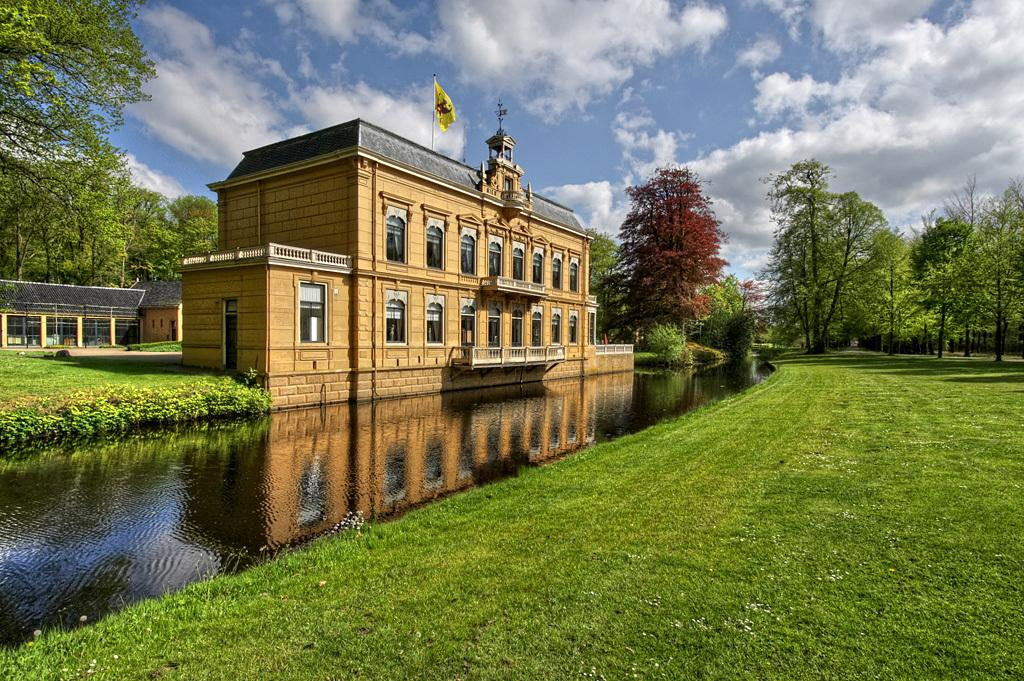What is located on the left side of the image? There are buildings, trees, a flag, water, and grass on the left side of the image. What is the composition of the left side of the image? The left side of the image includes natural elements like trees and water, as well as man-made structures like buildings and a flag. What is visible on the right side of the image? There is grass, sky, and clouds visible on the right side of the image. How does the right side of the image differ from the left side? The right side of the image features more natural elements, such as grass and sky, while the left side has a mix of natural and man-made elements. What type of breakfast is being served on the right side of the image? There is no breakfast visible in the image; it features natural elements like grass, sky, and clouds on the right side. Can you provide a receipt for the items on the left side of the image? There is no need for a receipt, as the image is a visual representation and not a transaction. 